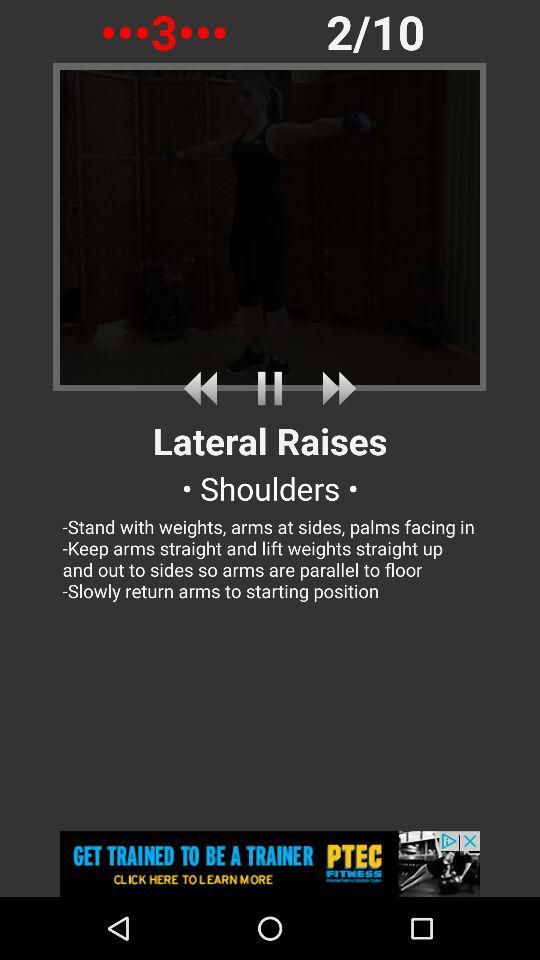What is the third step of the exercise?
Answer the question using a single word or phrase. Slowly return arms to starting position 